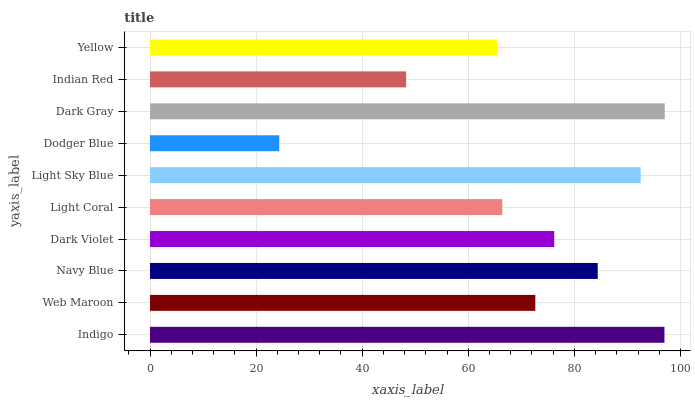Is Dodger Blue the minimum?
Answer yes or no. Yes. Is Dark Gray the maximum?
Answer yes or no. Yes. Is Web Maroon the minimum?
Answer yes or no. No. Is Web Maroon the maximum?
Answer yes or no. No. Is Indigo greater than Web Maroon?
Answer yes or no. Yes. Is Web Maroon less than Indigo?
Answer yes or no. Yes. Is Web Maroon greater than Indigo?
Answer yes or no. No. Is Indigo less than Web Maroon?
Answer yes or no. No. Is Dark Violet the high median?
Answer yes or no. Yes. Is Web Maroon the low median?
Answer yes or no. Yes. Is Web Maroon the high median?
Answer yes or no. No. Is Navy Blue the low median?
Answer yes or no. No. 